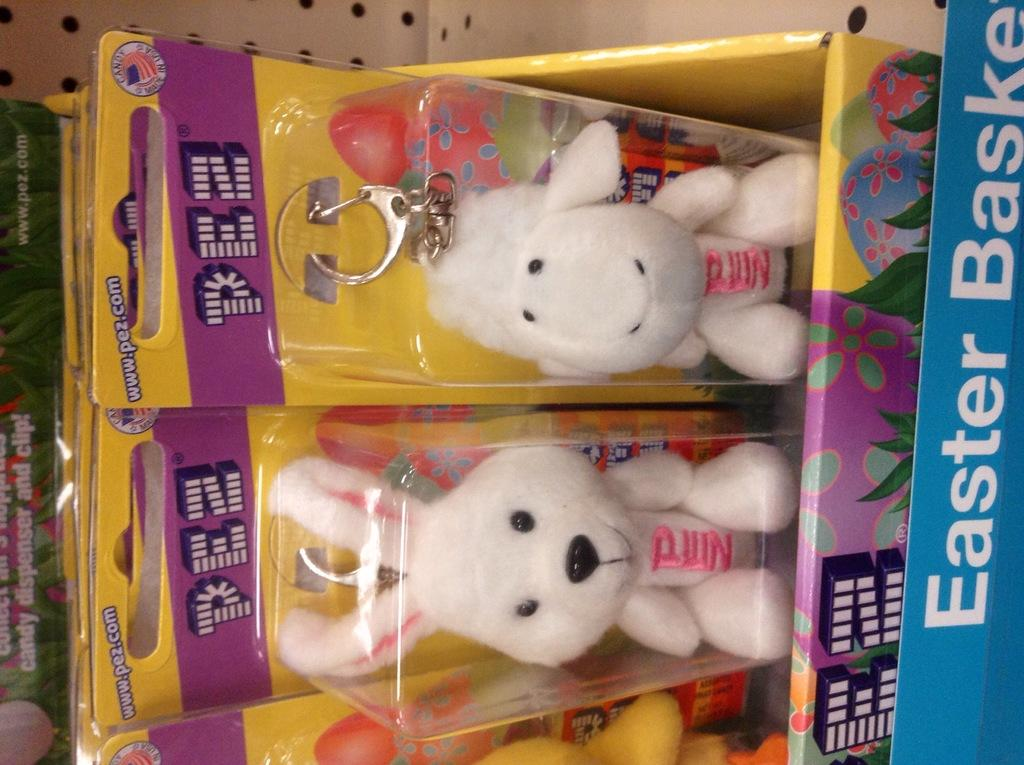What type of toys are in the image? There are toy kittens in the image. Where are the toy kittens located? The toy kittens are on a seal cover. Is there any text visible in the image? Yes, there is text visible in the image. Are there any volcanoes visible in the image? No, there are no volcanoes present in the image. How many snakes can be seen interacting with the toy kittens in the image? There are no snakes present in the image; it features toy kittens on a seal cover. 